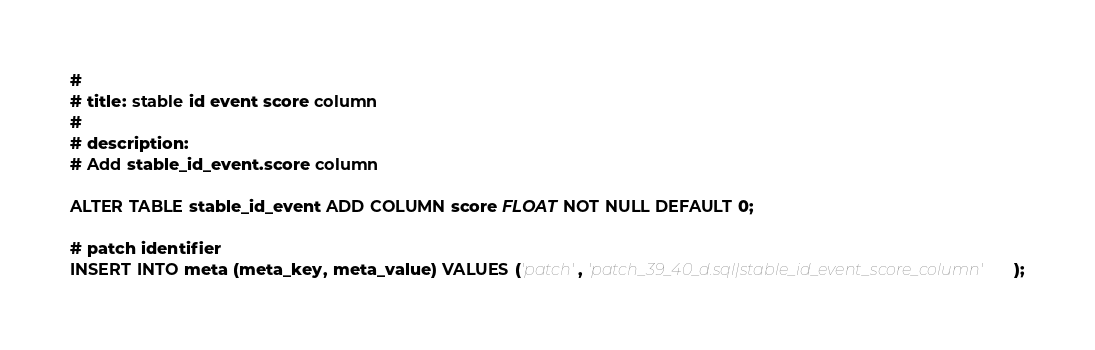<code> <loc_0><loc_0><loc_500><loc_500><_SQL_>#
# title: stable id event score column
#
# description:
# Add stable_id_event.score column

ALTER TABLE stable_id_event ADD COLUMN score FLOAT NOT NULL DEFAULT 0;

# patch identifier
INSERT INTO meta (meta_key, meta_value) VALUES ('patch', 'patch_39_40_d.sql|stable_id_event_score_column');

</code> 